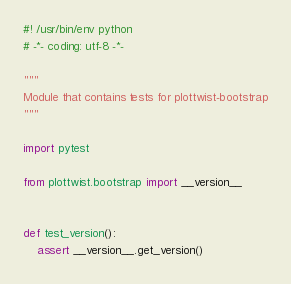<code> <loc_0><loc_0><loc_500><loc_500><_Python_>#! /usr/bin/env python
# -*- coding: utf-8 -*-

"""
Module that contains tests for plottwist-bootstrap
"""

import pytest

from plottwist.bootstrap import __version__


def test_version():
    assert __version__.get_version()
</code> 